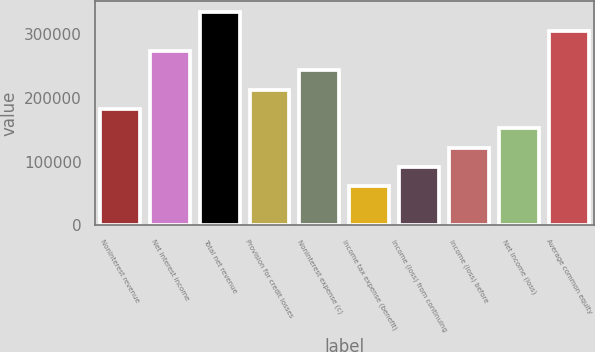<chart> <loc_0><loc_0><loc_500><loc_500><bar_chart><fcel>Noninterest revenue<fcel>Net interest income<fcel>Total net revenue<fcel>Provision for credit losses<fcel>Noninterest expense (c)<fcel>Income tax expense (benefit)<fcel>Income (loss) from continuing<fcel>Income (loss) before<fcel>Net income (loss)<fcel>Average common equity<nl><fcel>182667<fcel>273998<fcel>334886<fcel>213111<fcel>243555<fcel>60892.4<fcel>91336.1<fcel>121780<fcel>152224<fcel>304442<nl></chart> 